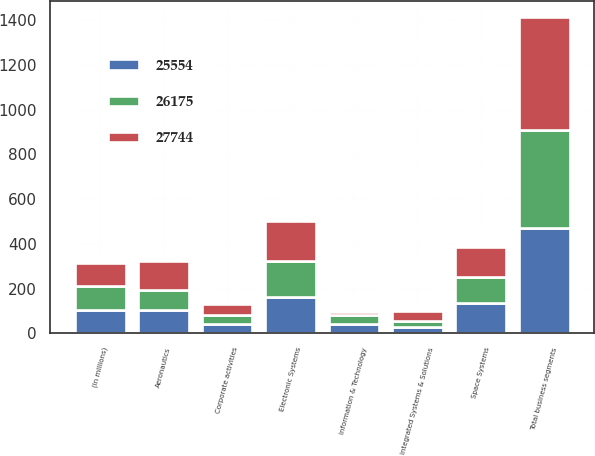<chart> <loc_0><loc_0><loc_500><loc_500><stacked_bar_chart><ecel><fcel>(In millions)<fcel>Aeronautics<fcel>Electronic Systems<fcel>Space Systems<fcel>Integrated Systems & Solutions<fcel>Information & Technology<fcel>Total business segments<fcel>Corporate activities<nl><fcel>27744<fcel>105<fcel>130<fcel>182<fcel>134<fcel>44<fcel>14<fcel>504<fcel>51<nl><fcel>25554<fcel>105<fcel>105<fcel>162<fcel>134<fcel>28<fcel>40<fcel>469<fcel>42<nl><fcel>26175<fcel>105<fcel>89<fcel>160<fcel>120<fcel>29<fcel>42<fcel>440<fcel>40<nl></chart> 